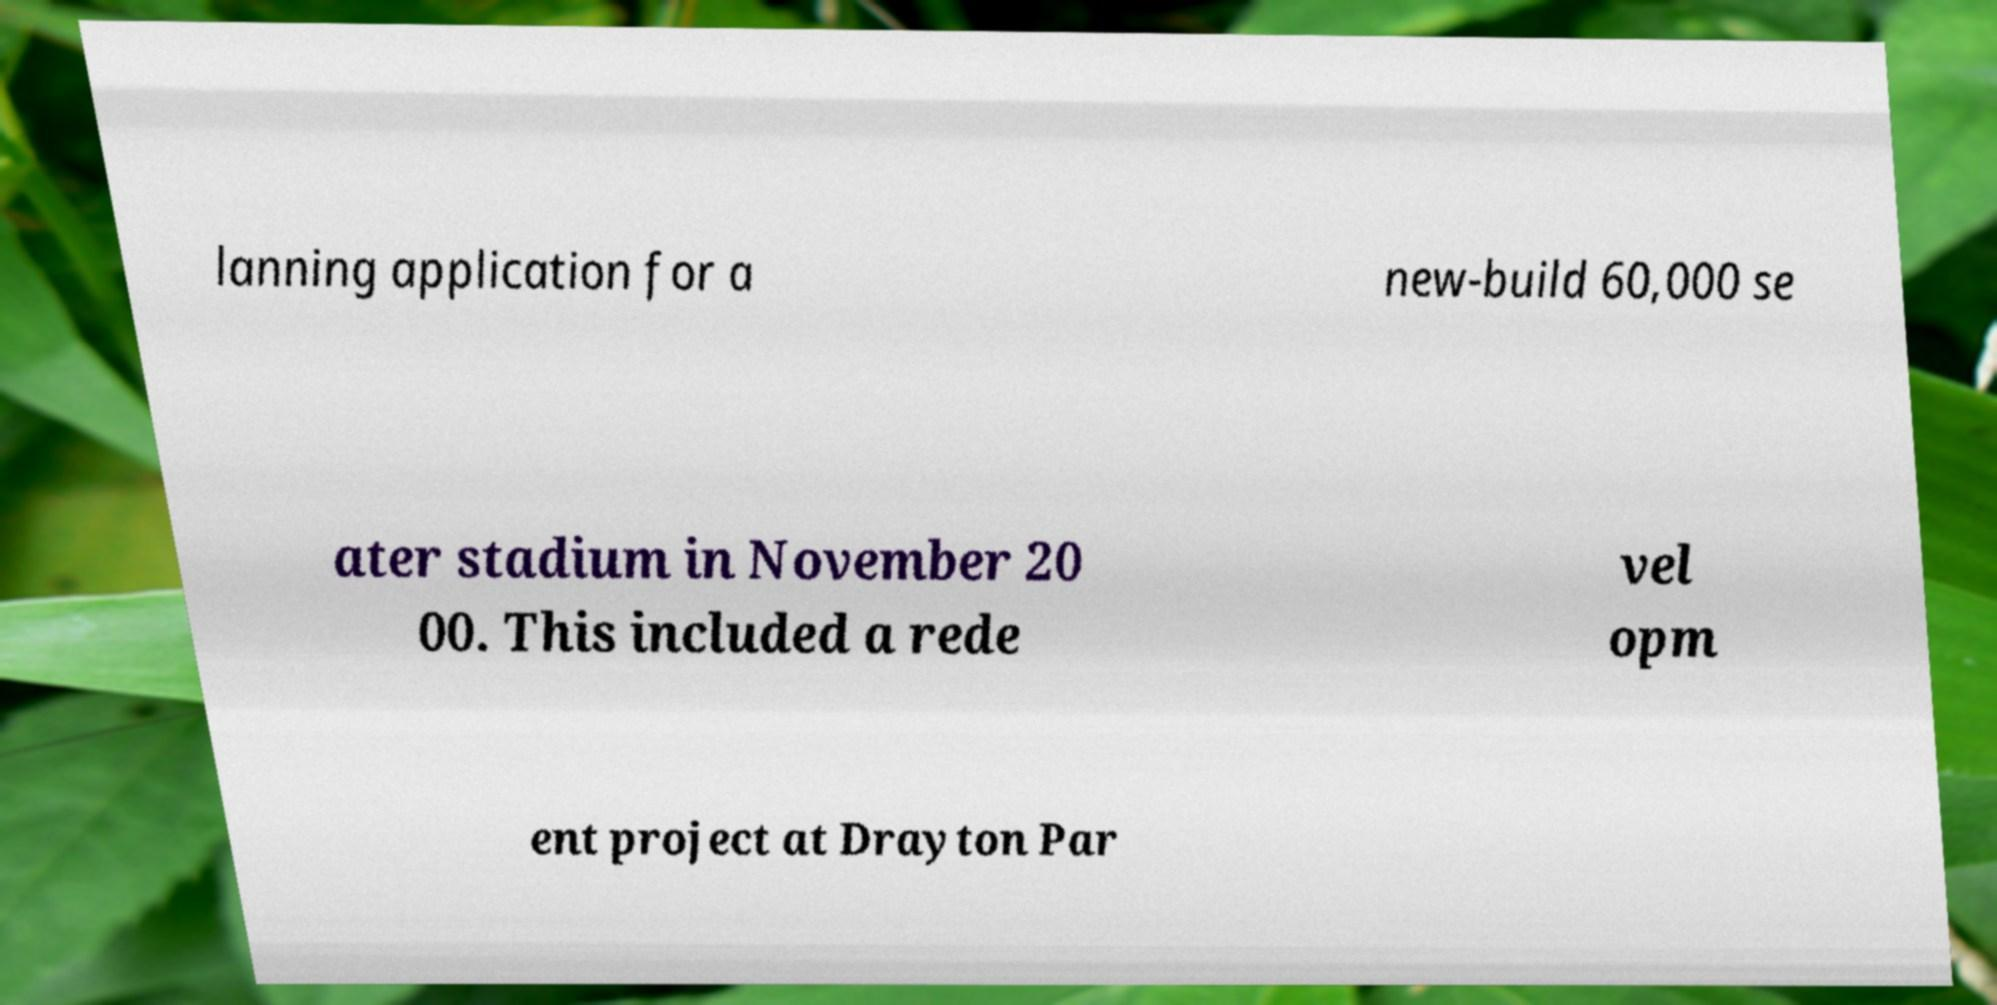Can you read and provide the text displayed in the image?This photo seems to have some interesting text. Can you extract and type it out for me? lanning application for a new-build 60,000 se ater stadium in November 20 00. This included a rede vel opm ent project at Drayton Par 